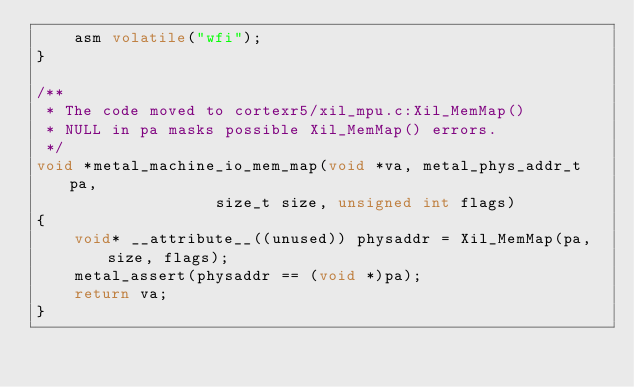<code> <loc_0><loc_0><loc_500><loc_500><_C_>	asm volatile("wfi");
}

/**
 * The code moved to cortexr5/xil_mpu.c:Xil_MemMap()
 * NULL in pa masks possible Xil_MemMap() errors.
 */
void *metal_machine_io_mem_map(void *va, metal_phys_addr_t pa,
			       size_t size, unsigned int flags)
{
	void* __attribute__((unused)) physaddr = Xil_MemMap(pa, size, flags);
	metal_assert(physaddr == (void *)pa);
	return va;
}
</code> 